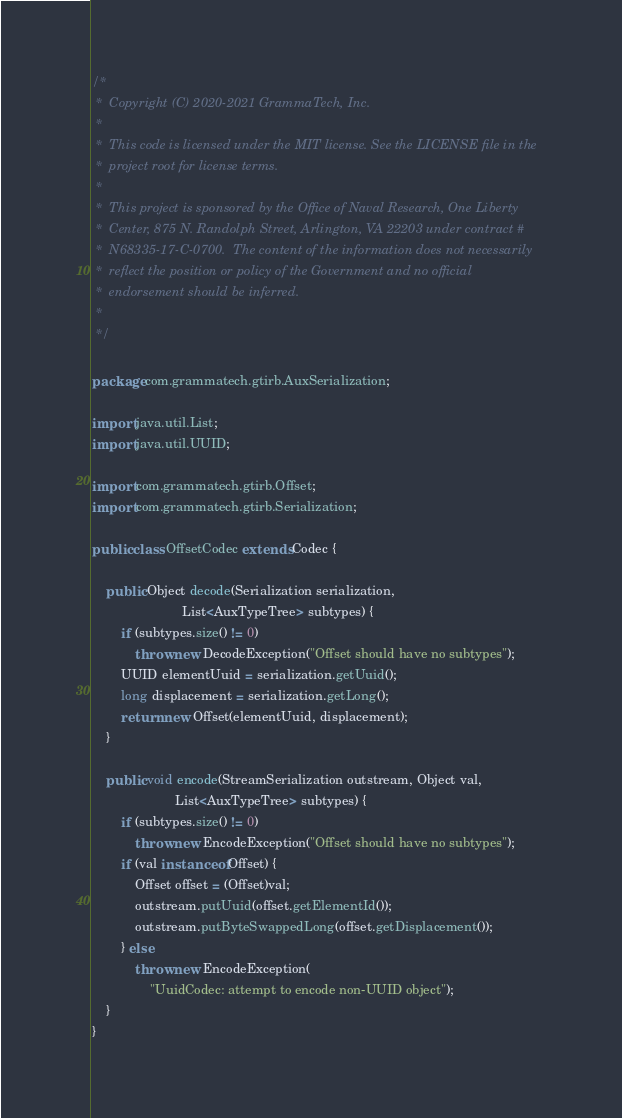Convert code to text. <code><loc_0><loc_0><loc_500><loc_500><_Java_>/*
 *  Copyright (C) 2020-2021 GrammaTech, Inc.
 *
 *  This code is licensed under the MIT license. See the LICENSE file in the
 *  project root for license terms.
 *
 *  This project is sponsored by the Office of Naval Research, One Liberty
 *  Center, 875 N. Randolph Street, Arlington, VA 22203 under contract #
 *  N68335-17-C-0700.  The content of the information does not necessarily
 *  reflect the position or policy of the Government and no official
 *  endorsement should be inferred.
 *
 */

package com.grammatech.gtirb.AuxSerialization;

import java.util.List;
import java.util.UUID;

import com.grammatech.gtirb.Offset;
import com.grammatech.gtirb.Serialization;

public class OffsetCodec extends Codec {

    public Object decode(Serialization serialization,
                         List<AuxTypeTree> subtypes) {
        if (subtypes.size() != 0)
            throw new DecodeException("Offset should have no subtypes");
        UUID elementUuid = serialization.getUuid();
        long displacement = serialization.getLong();
        return new Offset(elementUuid, displacement);
    }

    public void encode(StreamSerialization outstream, Object val,
                       List<AuxTypeTree> subtypes) {
        if (subtypes.size() != 0)
            throw new EncodeException("Offset should have no subtypes");
        if (val instanceof Offset) {
            Offset offset = (Offset)val;
            outstream.putUuid(offset.getElementId());
            outstream.putByteSwappedLong(offset.getDisplacement());
        } else
            throw new EncodeException(
                "UuidCodec: attempt to encode non-UUID object");
    }
}
</code> 